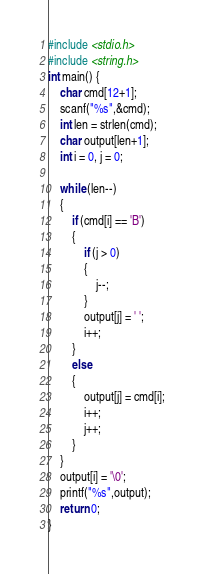Convert code to text. <code><loc_0><loc_0><loc_500><loc_500><_C++_>#include <stdio.h>
#include <string.h>
int main() {
	char cmd[12+1];
	scanf("%s",&cmd);
	int len = strlen(cmd);
	char output[len+1];
	int i = 0, j = 0;
	
	while (len--)
	{
		if (cmd[i] == 'B')
		{
			if (j > 0)
			{
				j--;
			}
			output[j] = ' ';
			i++;
		}
		else
		{
			output[j] = cmd[i];
			i++;
			j++;
		}
	}
	output[i] = '\0';
	printf("%s",output);
	return 0;
}</code> 